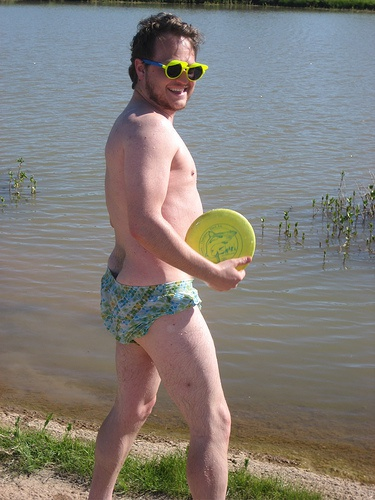Describe the objects in this image and their specific colors. I can see people in gray, brown, lightgray, and lightpink tones and frisbee in gray, olive, and khaki tones in this image. 